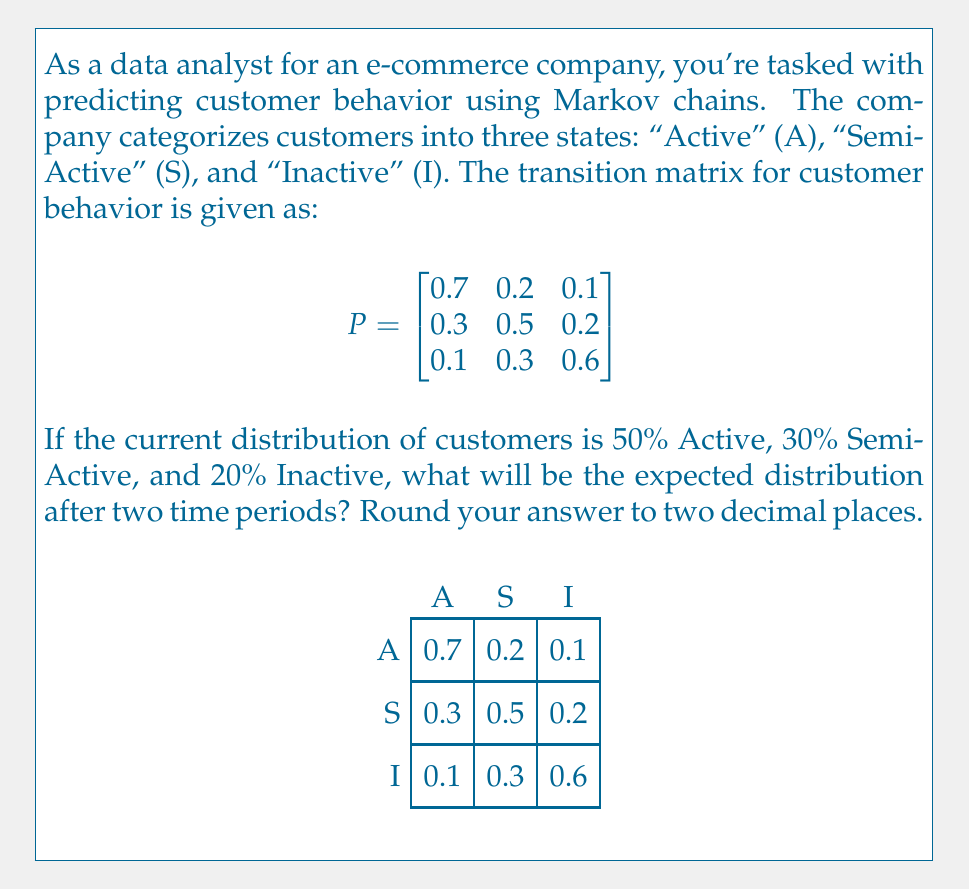Can you solve this math problem? Let's approach this step-by-step:

1) First, we need to represent the current distribution as a row vector:
   $\pi_0 = [0.5, 0.3, 0.2]$

2) To find the distribution after two time periods, we need to multiply this vector by the transition matrix twice:
   $\pi_2 = \pi_0 \cdot P^2$

3) Let's calculate $P^2$ first:
   $$P^2 = P \cdot P = \begin{bmatrix}
   0.7 & 0.2 & 0.1 \\
   0.3 & 0.5 & 0.2 \\
   0.1 & 0.3 & 0.6
   \end{bmatrix} \cdot \begin{bmatrix}
   0.7 & 0.2 & 0.1 \\
   0.3 & 0.5 & 0.2 \\
   0.1 & 0.3 & 0.6
   \end{bmatrix}$$

4) Performing the matrix multiplication:
   $$P^2 = \begin{bmatrix}
   0.55 & 0.28 & 0.17 \\
   0.37 & 0.41 & 0.22 \\
   0.22 & 0.36 & 0.42
   \end{bmatrix}$$

5) Now, we multiply $\pi_0$ by $P^2$:
   $\pi_2 = [0.5, 0.3, 0.2] \cdot \begin{bmatrix}
   0.55 & 0.28 & 0.17 \\
   0.37 & 0.41 & 0.22 \\
   0.22 & 0.36 & 0.42
   \end{bmatrix}$

6) Performing this multiplication:
   $\pi_2 = [0.5(0.55) + 0.3(0.37) + 0.2(0.22), 0.5(0.28) + 0.3(0.41) + 0.2(0.36), 0.5(0.17) + 0.3(0.22) + 0.2(0.42)]$

7) Calculating and rounding to two decimal places:
   $\pi_2 = [0.44, 0.33, 0.23]$

Therefore, after two time periods, the expected distribution of customers will be approximately 44% Active, 33% Semi-Active, and 23% Inactive.
Answer: [0.44, 0.33, 0.23] 